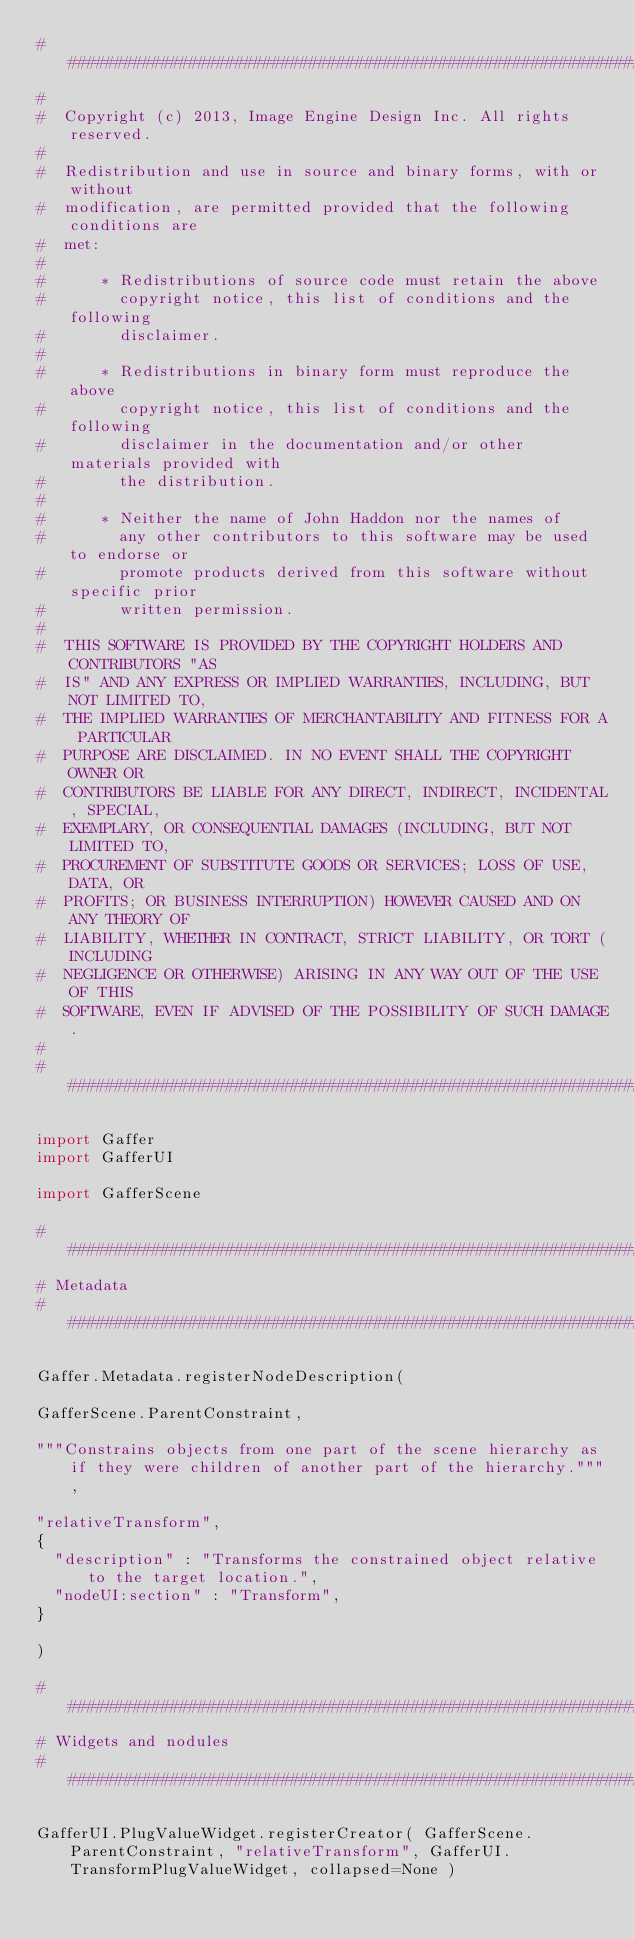<code> <loc_0><loc_0><loc_500><loc_500><_Python_>##########################################################################
#  
#  Copyright (c) 2013, Image Engine Design Inc. All rights reserved.
#  
#  Redistribution and use in source and binary forms, with or without
#  modification, are permitted provided that the following conditions are
#  met:
#  
#      * Redistributions of source code must retain the above
#        copyright notice, this list of conditions and the following
#        disclaimer.
#  
#      * Redistributions in binary form must reproduce the above
#        copyright notice, this list of conditions and the following
#        disclaimer in the documentation and/or other materials provided with
#        the distribution.
#  
#      * Neither the name of John Haddon nor the names of
#        any other contributors to this software may be used to endorse or
#        promote products derived from this software without specific prior
#        written permission.
#  
#  THIS SOFTWARE IS PROVIDED BY THE COPYRIGHT HOLDERS AND CONTRIBUTORS "AS
#  IS" AND ANY EXPRESS OR IMPLIED WARRANTIES, INCLUDING, BUT NOT LIMITED TO,
#  THE IMPLIED WARRANTIES OF MERCHANTABILITY AND FITNESS FOR A PARTICULAR
#  PURPOSE ARE DISCLAIMED. IN NO EVENT SHALL THE COPYRIGHT OWNER OR
#  CONTRIBUTORS BE LIABLE FOR ANY DIRECT, INDIRECT, INCIDENTAL, SPECIAL,
#  EXEMPLARY, OR CONSEQUENTIAL DAMAGES (INCLUDING, BUT NOT LIMITED TO,
#  PROCUREMENT OF SUBSTITUTE GOODS OR SERVICES; LOSS OF USE, DATA, OR
#  PROFITS; OR BUSINESS INTERRUPTION) HOWEVER CAUSED AND ON ANY THEORY OF
#  LIABILITY, WHETHER IN CONTRACT, STRICT LIABILITY, OR TORT (INCLUDING
#  NEGLIGENCE OR OTHERWISE) ARISING IN ANY WAY OUT OF THE USE OF THIS
#  SOFTWARE, EVEN IF ADVISED OF THE POSSIBILITY OF SUCH DAMAGE.
#  
##########################################################################

import Gaffer
import GafferUI

import GafferScene

##########################################################################
# Metadata
##########################################################################

Gaffer.Metadata.registerNodeDescription(

GafferScene.ParentConstraint,

"""Constrains objects from one part of the scene hierarchy as if they were children of another part of the hierarchy.""",

"relativeTransform",
{
	"description" : "Transforms the constrained object relative to the target location.",
	"nodeUI:section" : "Transform",
}

)

##########################################################################
# Widgets and nodules
##########################################################################

GafferUI.PlugValueWidget.registerCreator( GafferScene.ParentConstraint, "relativeTransform", GafferUI.TransformPlugValueWidget, collapsed=None )

</code> 